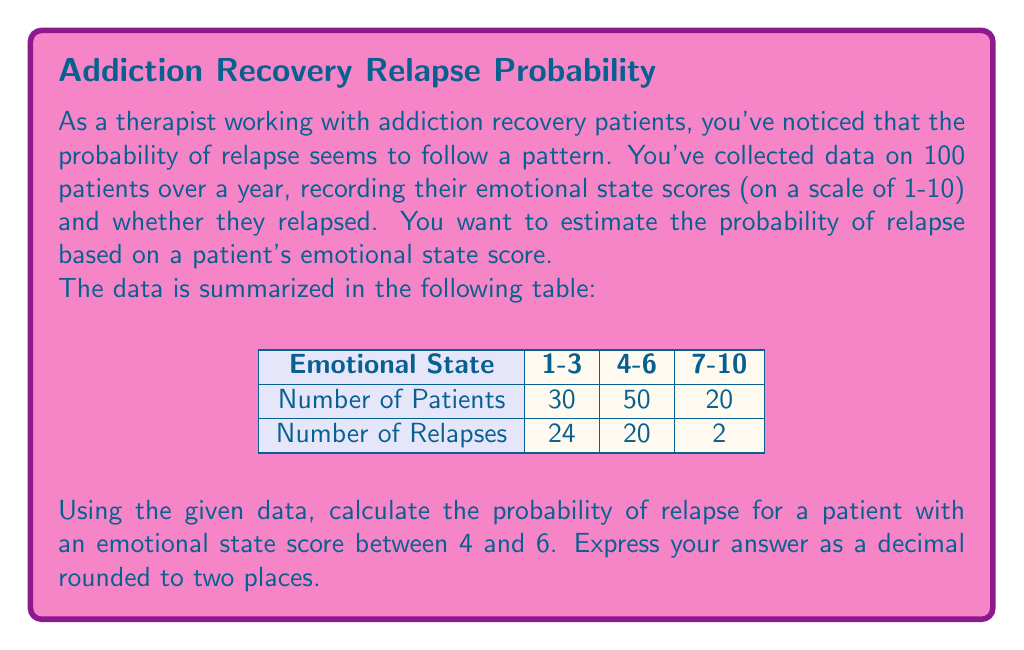Can you answer this question? Let's approach this step-by-step:

1) First, we need to identify the relevant information from the table:
   - There are 50 patients with emotional state scores between 4 and 6
   - Out of these 50 patients, 20 experienced a relapse

2) To calculate the probability of relapse for patients in this emotional state range, we use the formula:

   $$P(\text{Relapse}) = \frac{\text{Number of Relapses}}{\text{Total Number of Patients}}$$

3) Substituting the values:

   $$P(\text{Relapse}) = \frac{20}{50}$$

4) Simplify the fraction:

   $$P(\text{Relapse}) = \frac{2}{5} = 0.4$$

5) The question asks for the answer rounded to two decimal places, so 0.40 is our final answer.

This probability suggests that for patients with emotional state scores between 4 and 6, there's a 40% chance of relapse. As a therapist, this information could be valuable in identifying patients who might need additional support or interventions to prevent relapse.
Answer: 0.40 